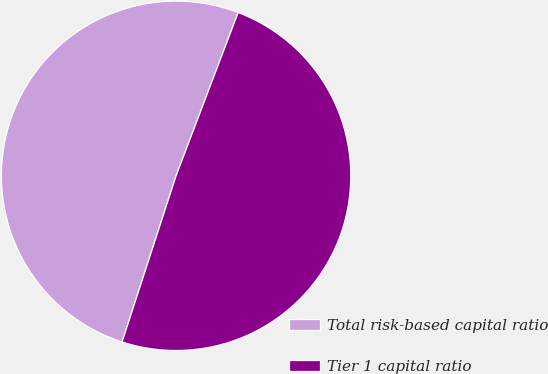Convert chart to OTSL. <chart><loc_0><loc_0><loc_500><loc_500><pie_chart><fcel>Total risk-based capital ratio<fcel>Tier 1 capital ratio<nl><fcel>50.78%<fcel>49.22%<nl></chart> 